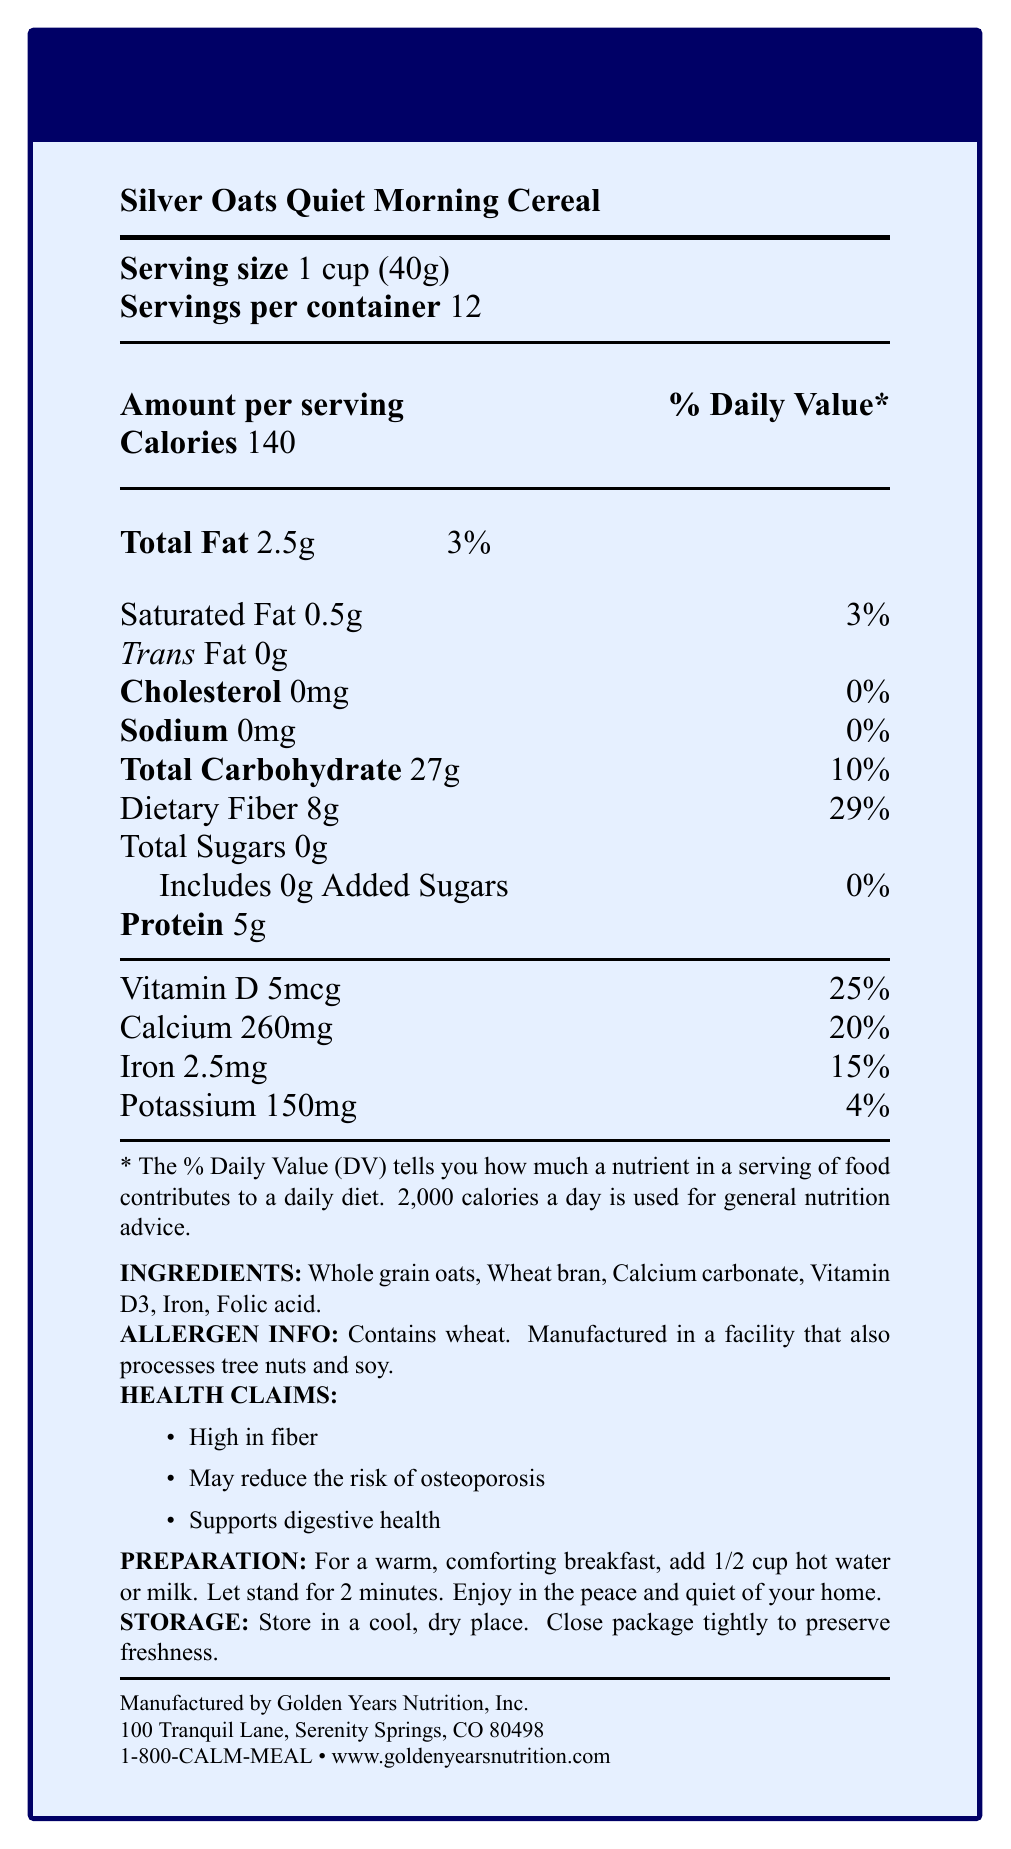What is the serving size of Silver Oats Quiet Morning Cereal? The serving size is explicitly stated as "1 cup (40g)" in the document.
Answer: 1 cup (40g) How many servings are there in one container of the cereal? The document mentions "Servings per container: 12".
Answer: 12 How much dietary fiber is in one serving of the cereal? The document indicates "Dietary Fiber 8g".
Answer: 8g Is the cereal sugar-free? The document lists "Total Sugars: 0g" and "Includes 0g Added Sugars".
Answer: Yes What is the daily value percentage of calcium in one serving? The document specifies "Calcium 260mg \hfill 20%".
Answer: 20% What are the ingredients of the cereal? A. Whole grain oats, wheat bran, calcium carbonate B. Rice, sugar, wheat bran C. Corn, whole grain oats, folic acid D. Whole grain oats, soy, rice The ingredients listed are "Whole grain oats, Wheat bran, Calcium carbonate, Vitamin D3, Iron, Folic acid".
Answer: A. Whole grain oats, wheat bran, calcium carbonate What are the health claims associated with the cereal? A. High in fiber B. Reduces cholesterol C. May reduce the risk of osteoporosis D. Supports digestive health The health claims specified are "High in fiber", "May reduce the risk of osteoporosis", and "Supports digestive health".
Answer: A, C, D Does the cereal contain any cholesterol? The document lists "Cholesterol: 0mg".
Answer: No How many calories are in one serving of the cereal? The document states "Calories 140".
Answer: 140 Which company manufactures the cereal? The manufacturer is mentioned as "Golden Years Nutrition, Inc." in the document.
Answer: Golden Years Nutrition, Inc. What is the total fat content per serving, in grams? The document lists "Total Fat 2.5g".
Answer: 2.5g What is the correct preparation instruction for the cereal? The preparation instructions are "For a warm, comforting breakfast, add 1/2 cup hot water or milk. Let stand for 2 minutes."
Answer: Add 1/2 cup hot water or milk, let stand for 2 minutes What are some of the vitamin or mineral contents in the cereal? The document specifies "Vitamin D 5mcg, Calcium 260mg, Iron 2.5mg, Potassium 150mg".
Answer: Vitamin D, Calcium, Iron, Potassium What is the sodium content of the cereal? The document lists "Sodium: 0mg".
Answer: 0mg How does the cereal support bone health? The document highlights that the cereal is rich in calcium (260mg, 20% DV) and Vitamin D (5mcg, 25% DV).
Answer: Contains calcium and Vitamin D How should the cereal be stored? The storage instructions mentioned are "Store in a cool, dry place. Close package tightly to preserve freshness."
Answer: Store in a cool, dry place. Close package tightly to preserve freshness. What percentage of daily value for dietary fiber does one serving of the cereal provide? The document states "Dietary Fiber 8g \hfill 29%".
Answer: 29% Does the cereal contain any allergens? The allergen information states "Contains wheat. Manufactured in a facility that also processes tree nuts and soy."
Answer: Yes What is the complete nutritional breakdown of the cereal? There is not enough information provided in a single part of the document for a complete breakdown.
Answer: Cannot be determined Summarize the main features and nutritional highlights of the cereal. The document provides detailed information on serving size, nutritional value, ingredients, health claims, preparation, storage instructions, and manufacturer details. The cereal is notable for being high in dietary fiber, calcium, and vitamin D.
Answer: Silver Oats Quiet Morning Cereal is a high-fiber, sugar-free breakfast cereal that is rich in calcium and vitamin D, aiming to support bone and digestive health. It has 140 calories per serving and contains whole grain oats, wheat bran, and essential vitamins and minerals. 